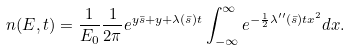Convert formula to latex. <formula><loc_0><loc_0><loc_500><loc_500>n ( E , t ) = \frac { 1 } { E _ { 0 } } \frac { 1 } { 2 \pi } e ^ { y \bar { s } + y + \lambda ( \bar { s } ) t } \int _ { - \infty } ^ { \infty } e ^ { - \frac { 1 } { 2 } \lambda ^ { \prime \prime } ( \bar { s } ) t x ^ { 2 } } d x .</formula> 